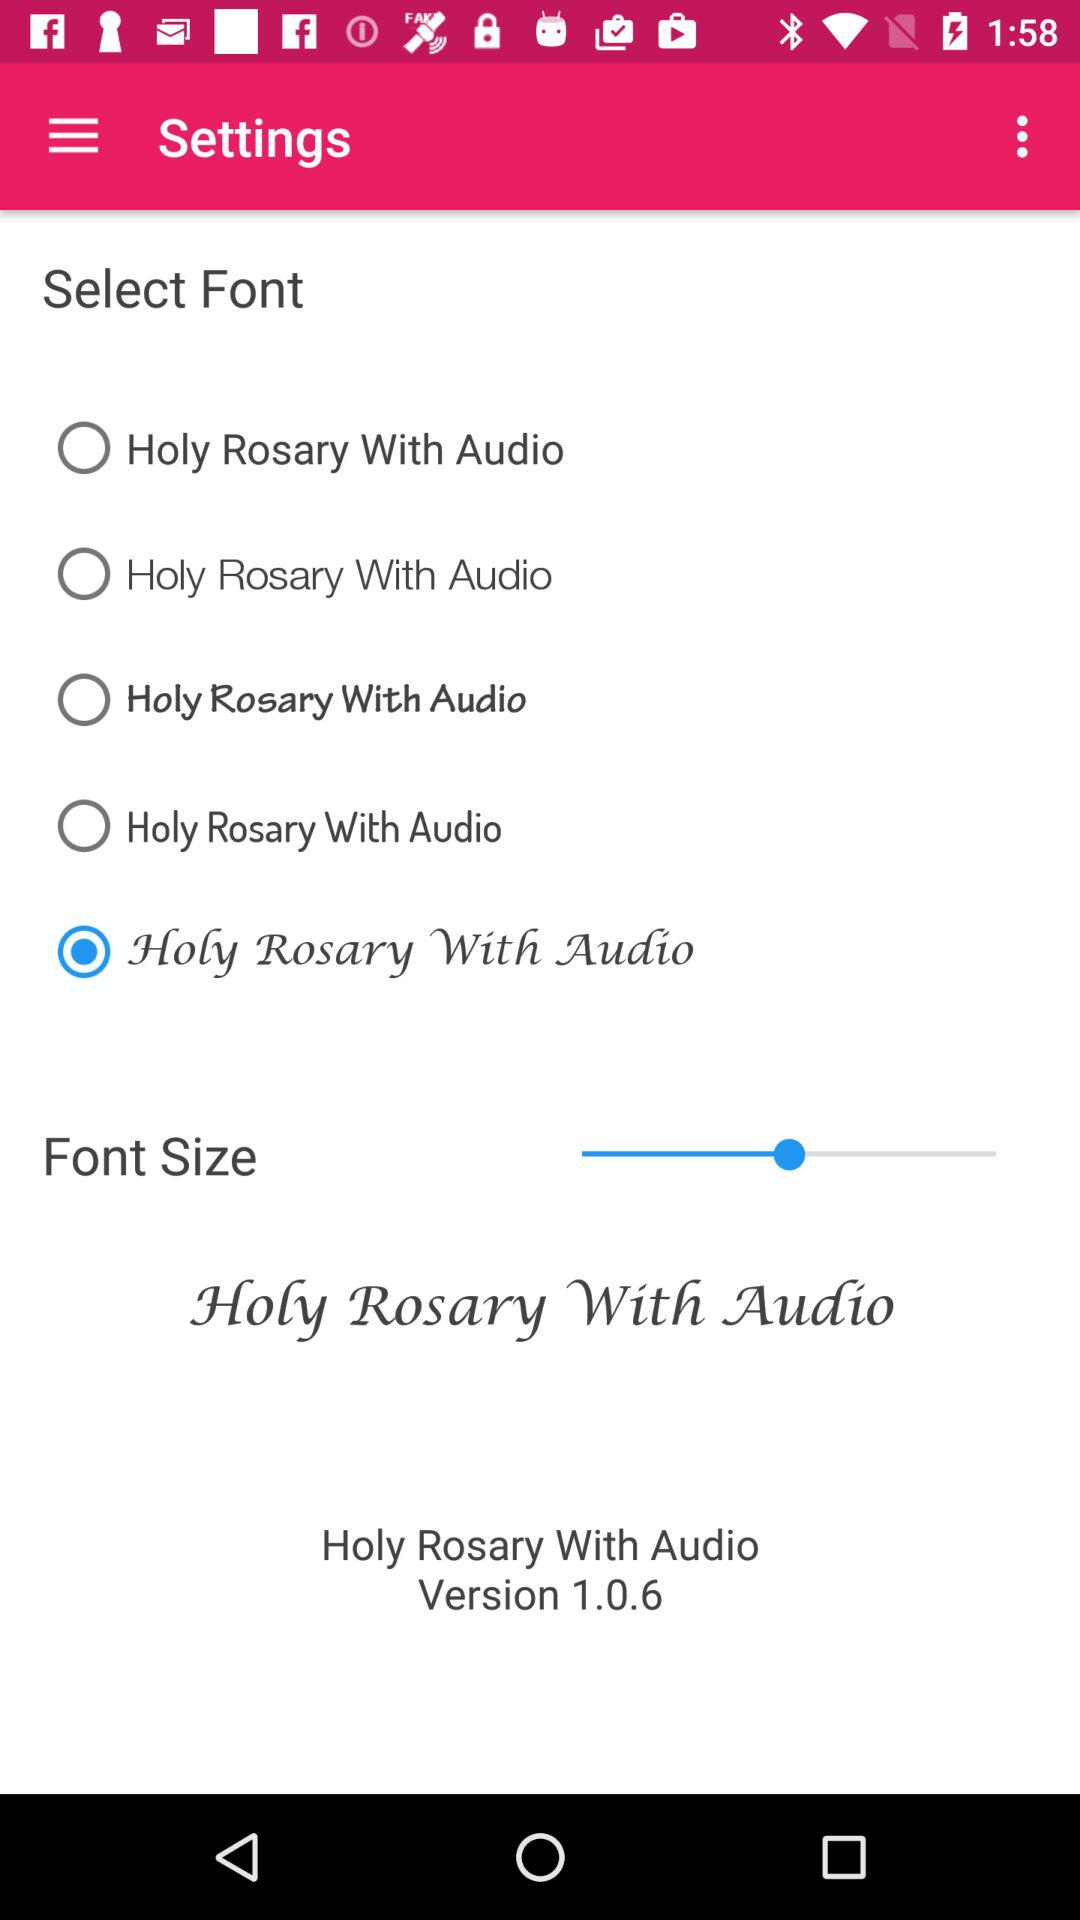What is the version? The version is 1.0.6. 